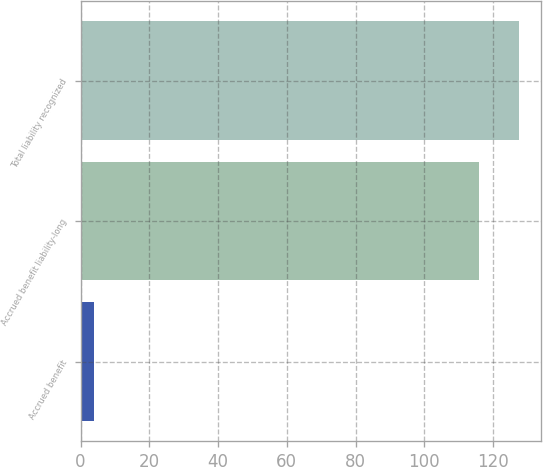<chart> <loc_0><loc_0><loc_500><loc_500><bar_chart><fcel>Accrued benefit<fcel>Accrued benefit liability-long<fcel>Total liability recognized<nl><fcel>4<fcel>116<fcel>127.6<nl></chart> 